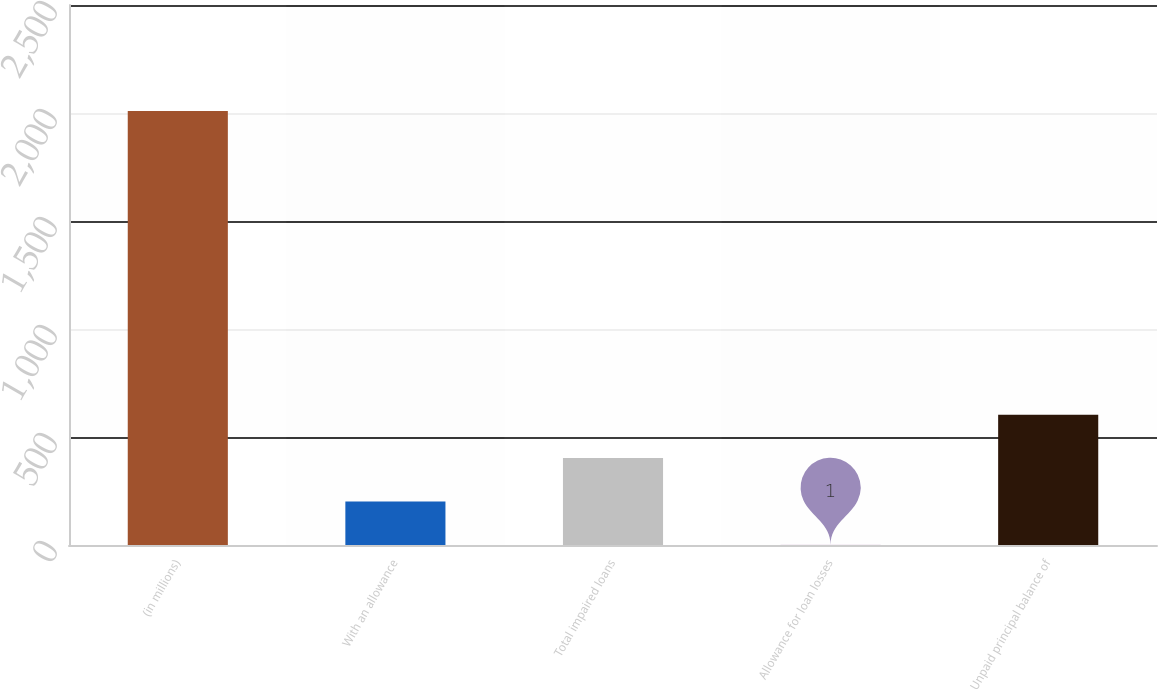Convert chart to OTSL. <chart><loc_0><loc_0><loc_500><loc_500><bar_chart><fcel>(in millions)<fcel>With an allowance<fcel>Total impaired loans<fcel>Allowance for loan losses<fcel>Unpaid principal balance of<nl><fcel>2009<fcel>201.8<fcel>402.6<fcel>1<fcel>603.4<nl></chart> 